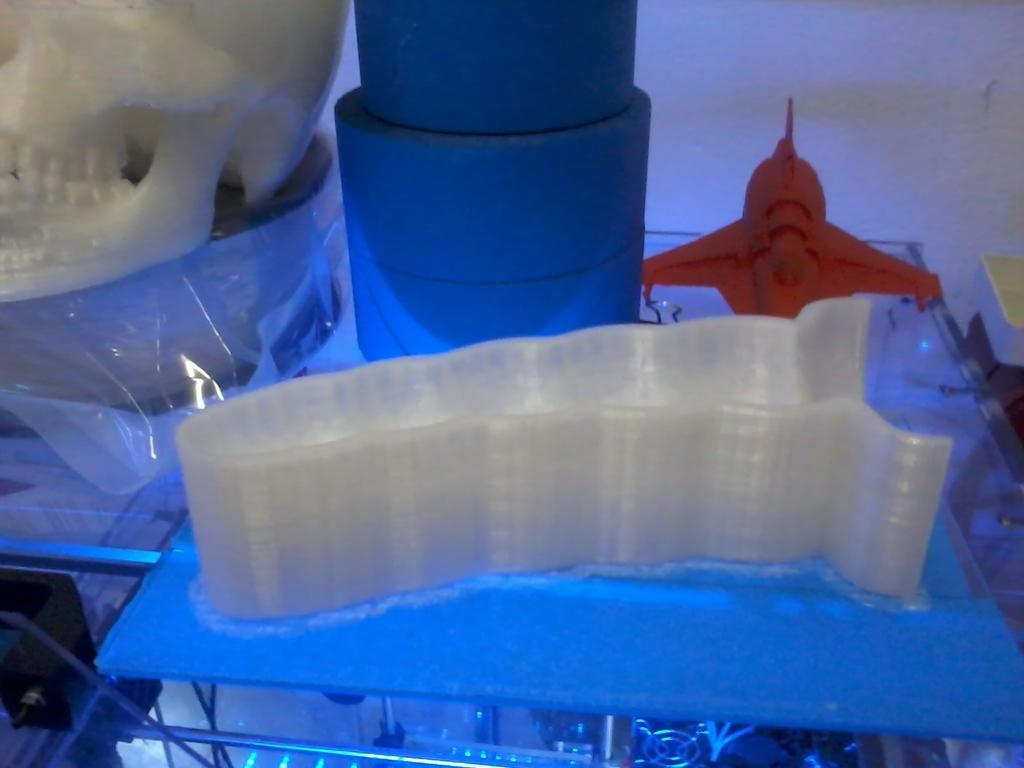What types of items are visible in the image? There are objects in the image that look like toys. Where are the toys located in the image? The toys are placed on a table. How many kittens are playing with the toys in the image? There are no kittens present in the image; it only features toys placed on a table. What time of day is it in the image, considering the position of the sun? There is no reference to the sun or time of day in the image, as it only shows toys placed on a table. 